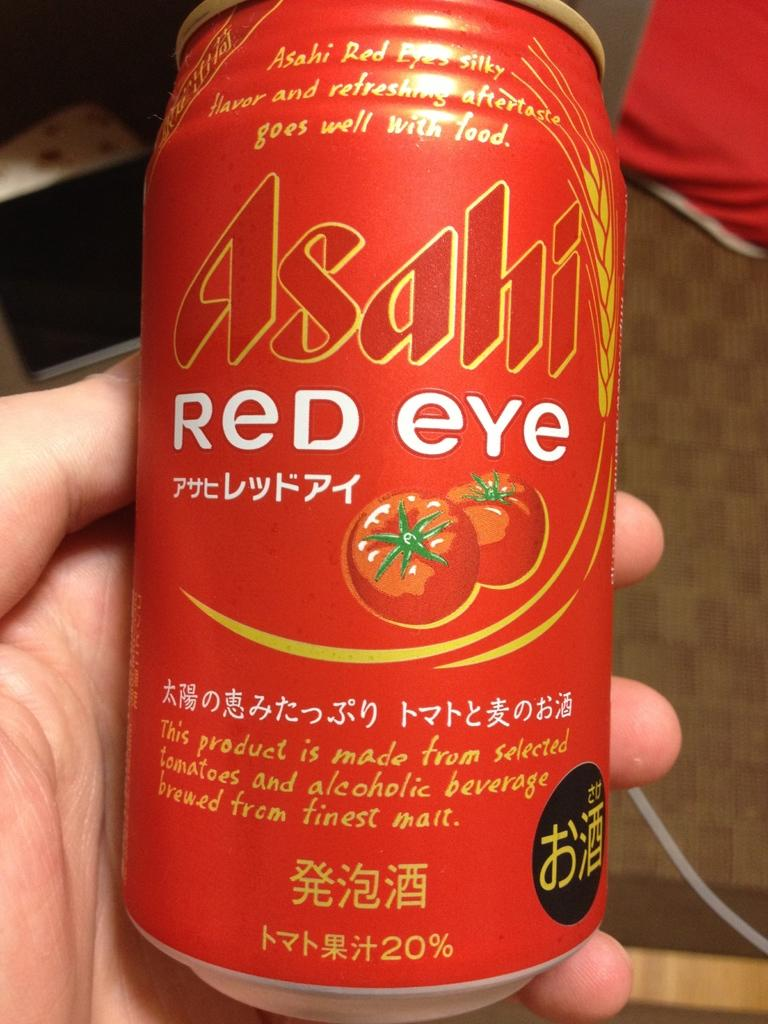<image>
Share a concise interpretation of the image provided. A bottle has the brand name Asahi on it and is red. 